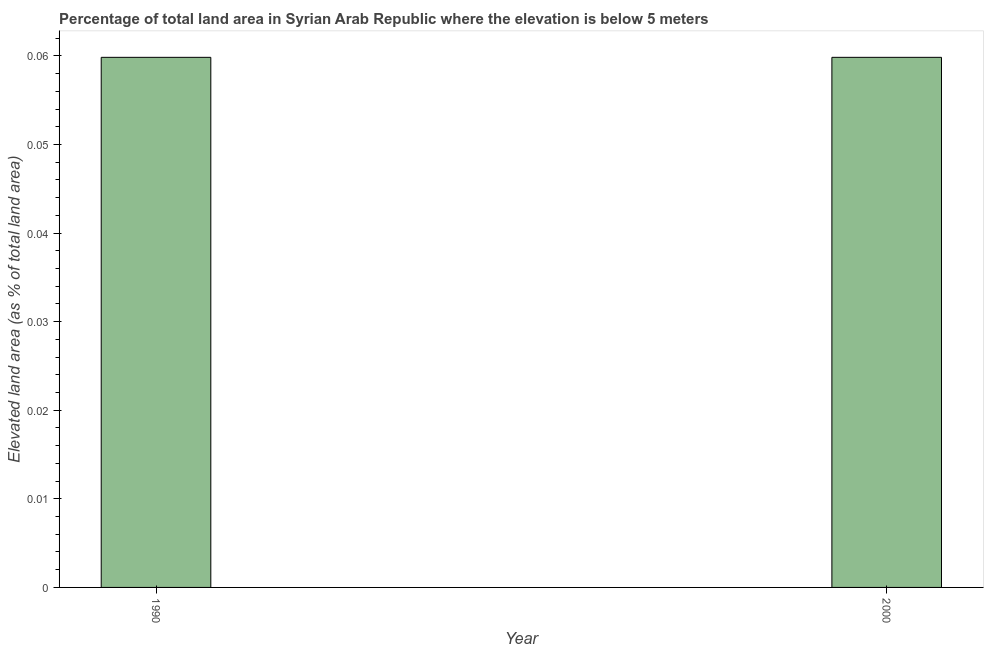What is the title of the graph?
Offer a terse response. Percentage of total land area in Syrian Arab Republic where the elevation is below 5 meters. What is the label or title of the Y-axis?
Ensure brevity in your answer.  Elevated land area (as % of total land area). What is the total elevated land area in 2000?
Provide a short and direct response. 0.06. Across all years, what is the maximum total elevated land area?
Your response must be concise. 0.06. Across all years, what is the minimum total elevated land area?
Keep it short and to the point. 0.06. What is the sum of the total elevated land area?
Provide a short and direct response. 0.12. What is the median total elevated land area?
Offer a terse response. 0.06. Do a majority of the years between 1990 and 2000 (inclusive) have total elevated land area greater than 0.034 %?
Keep it short and to the point. Yes. What is the ratio of the total elevated land area in 1990 to that in 2000?
Keep it short and to the point. 1. Are all the bars in the graph horizontal?
Your response must be concise. No. How many years are there in the graph?
Offer a terse response. 2. What is the Elevated land area (as % of total land area) in 1990?
Your answer should be very brief. 0.06. What is the Elevated land area (as % of total land area) of 2000?
Ensure brevity in your answer.  0.06. What is the difference between the Elevated land area (as % of total land area) in 1990 and 2000?
Provide a short and direct response. 0. What is the ratio of the Elevated land area (as % of total land area) in 1990 to that in 2000?
Offer a very short reply. 1. 